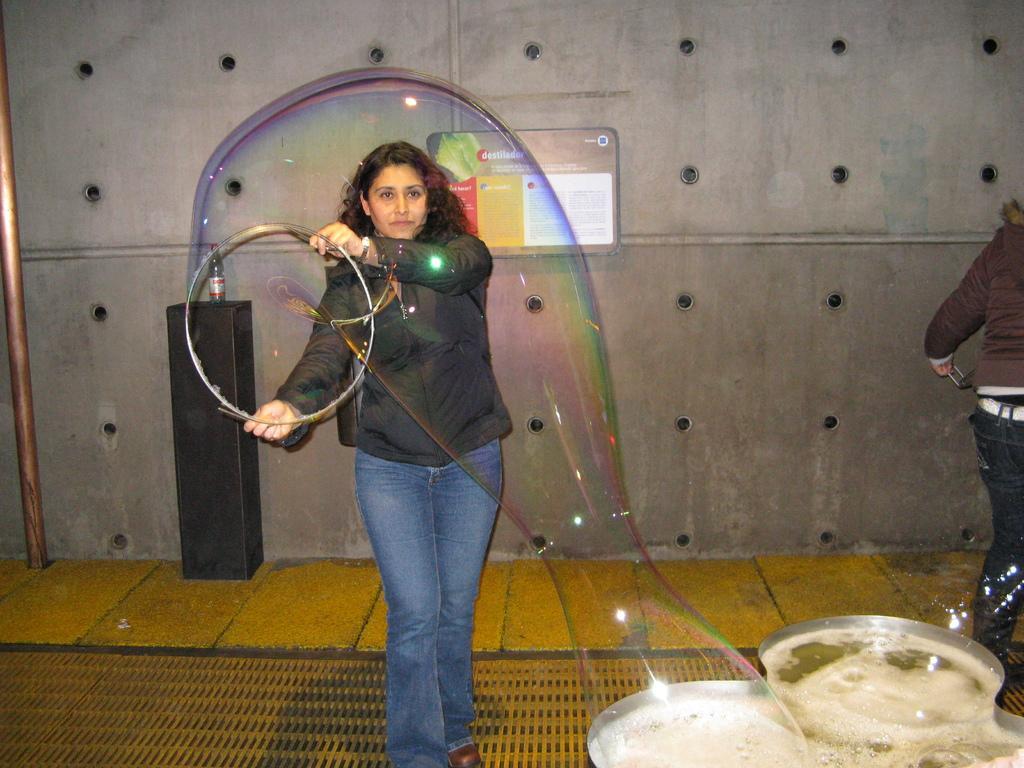Could you give a brief overview of what you see in this image? In this image there is a person holding a ring and creating a water bubble and there is water in the bucket, there is a another person, a pole, a bottle on the stand, a few holes in the wall, a frame attached to the wall. 